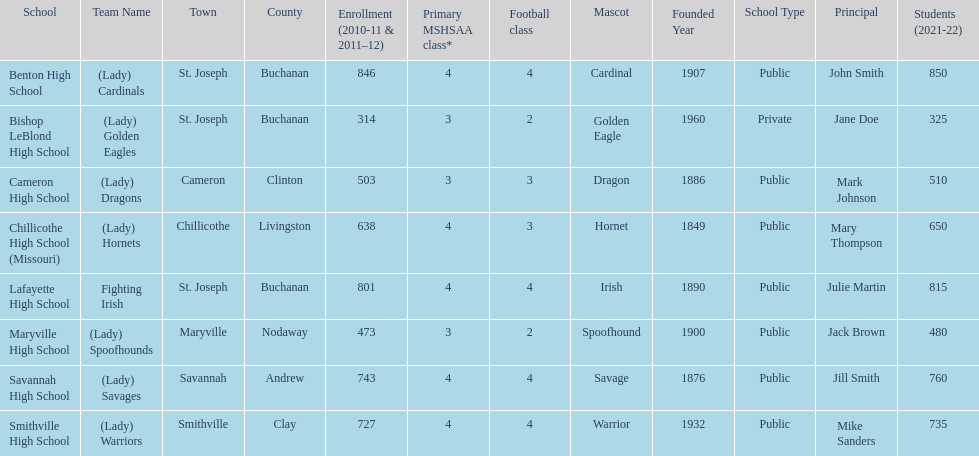What are the names of the schools? Benton High School, Bishop LeBlond High School, Cameron High School, Chillicothe High School (Missouri), Lafayette High School, Maryville High School, Savannah High School, Smithville High School. Of those, which had a total enrollment of less than 500? Bishop LeBlond High School, Maryville High School. And of those, which had the lowest enrollment? Bishop LeBlond High School. 